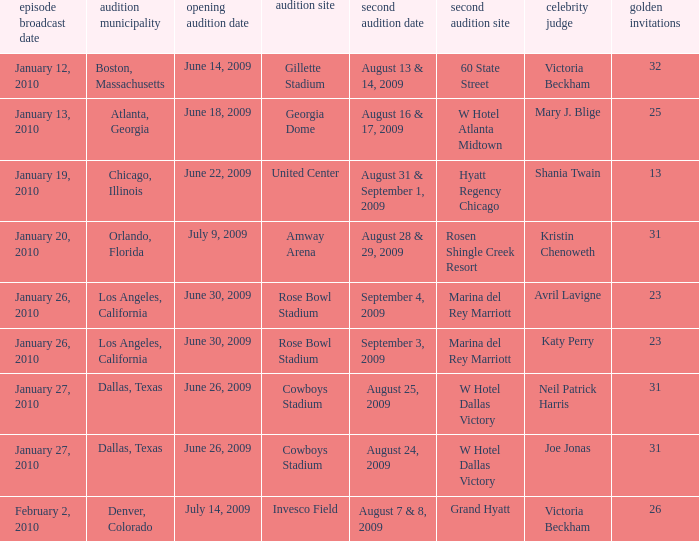Name the guest judge for first audition date being july 9, 2009 1.0. 